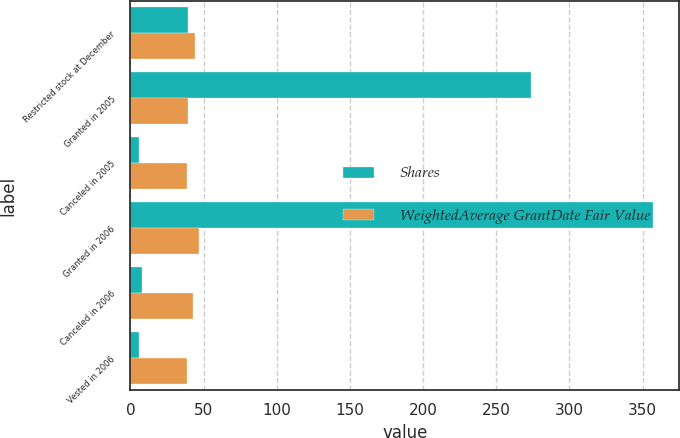Convert chart. <chart><loc_0><loc_0><loc_500><loc_500><stacked_bar_chart><ecel><fcel>Restricted stock at December<fcel>Granted in 2005<fcel>Canceled in 2005<fcel>Granted in 2006<fcel>Canceled in 2006<fcel>Vested in 2006<nl><fcel>Shares<fcel>39.58<fcel>274<fcel>6<fcel>357<fcel>8<fcel>6<nl><fcel>WeightedAverage GrantDate Fair Value<fcel>43.84<fcel>39.55<fcel>38.75<fcel>46.96<fcel>42.92<fcel>38.75<nl></chart> 